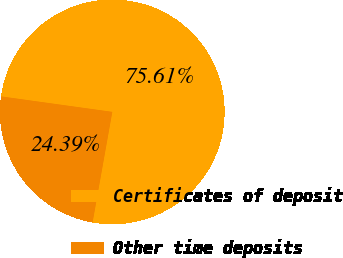Convert chart. <chart><loc_0><loc_0><loc_500><loc_500><pie_chart><fcel>Certificates of deposit<fcel>Other time deposits<nl><fcel>75.61%<fcel>24.39%<nl></chart> 